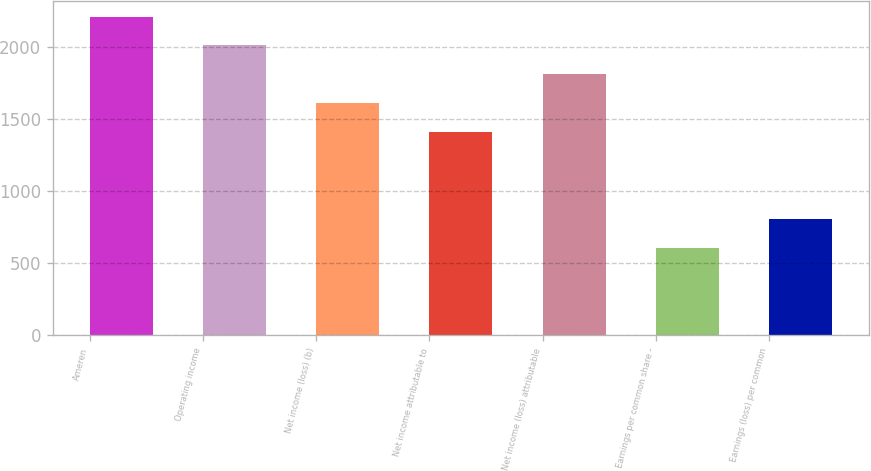<chart> <loc_0><loc_0><loc_500><loc_500><bar_chart><fcel>Ameren<fcel>Operating income<fcel>Net income (loss) (b)<fcel>Net income attributable to<fcel>Net income (loss) attributable<fcel>Earnings per common share -<fcel>Earnings (loss) per common<nl><fcel>2213.16<fcel>2011.99<fcel>1609.65<fcel>1408.48<fcel>1810.82<fcel>603.8<fcel>804.97<nl></chart> 